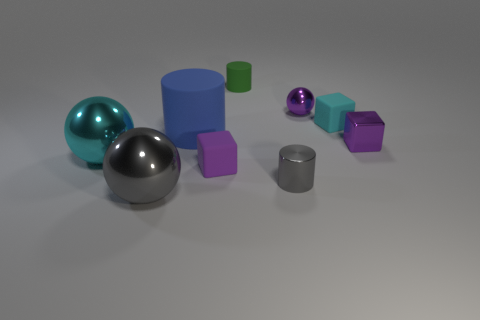What color is the metal object that is the same shape as the tiny green matte thing?
Ensure brevity in your answer.  Gray. Is the number of small cubes that are behind the tiny cyan object less than the number of purple balls?
Provide a succinct answer. Yes. Are there any small cyan cubes on the right side of the big rubber cylinder?
Keep it short and to the point. Yes. Are there any large rubber objects of the same shape as the tiny purple matte thing?
Ensure brevity in your answer.  No. There is a purple rubber thing that is the same size as the purple metallic sphere; what shape is it?
Make the answer very short. Cube. How many things are matte things on the right side of the big rubber cylinder or small green things?
Provide a succinct answer. 3. Is the metal cube the same color as the big matte cylinder?
Provide a succinct answer. No. There is a sphere in front of the large cyan sphere; what is its size?
Offer a terse response. Large. Is there a red rubber cylinder of the same size as the purple matte block?
Make the answer very short. No. There is a purple block that is on the right side of the gray metal cylinder; is its size the same as the large blue cylinder?
Provide a succinct answer. No. 